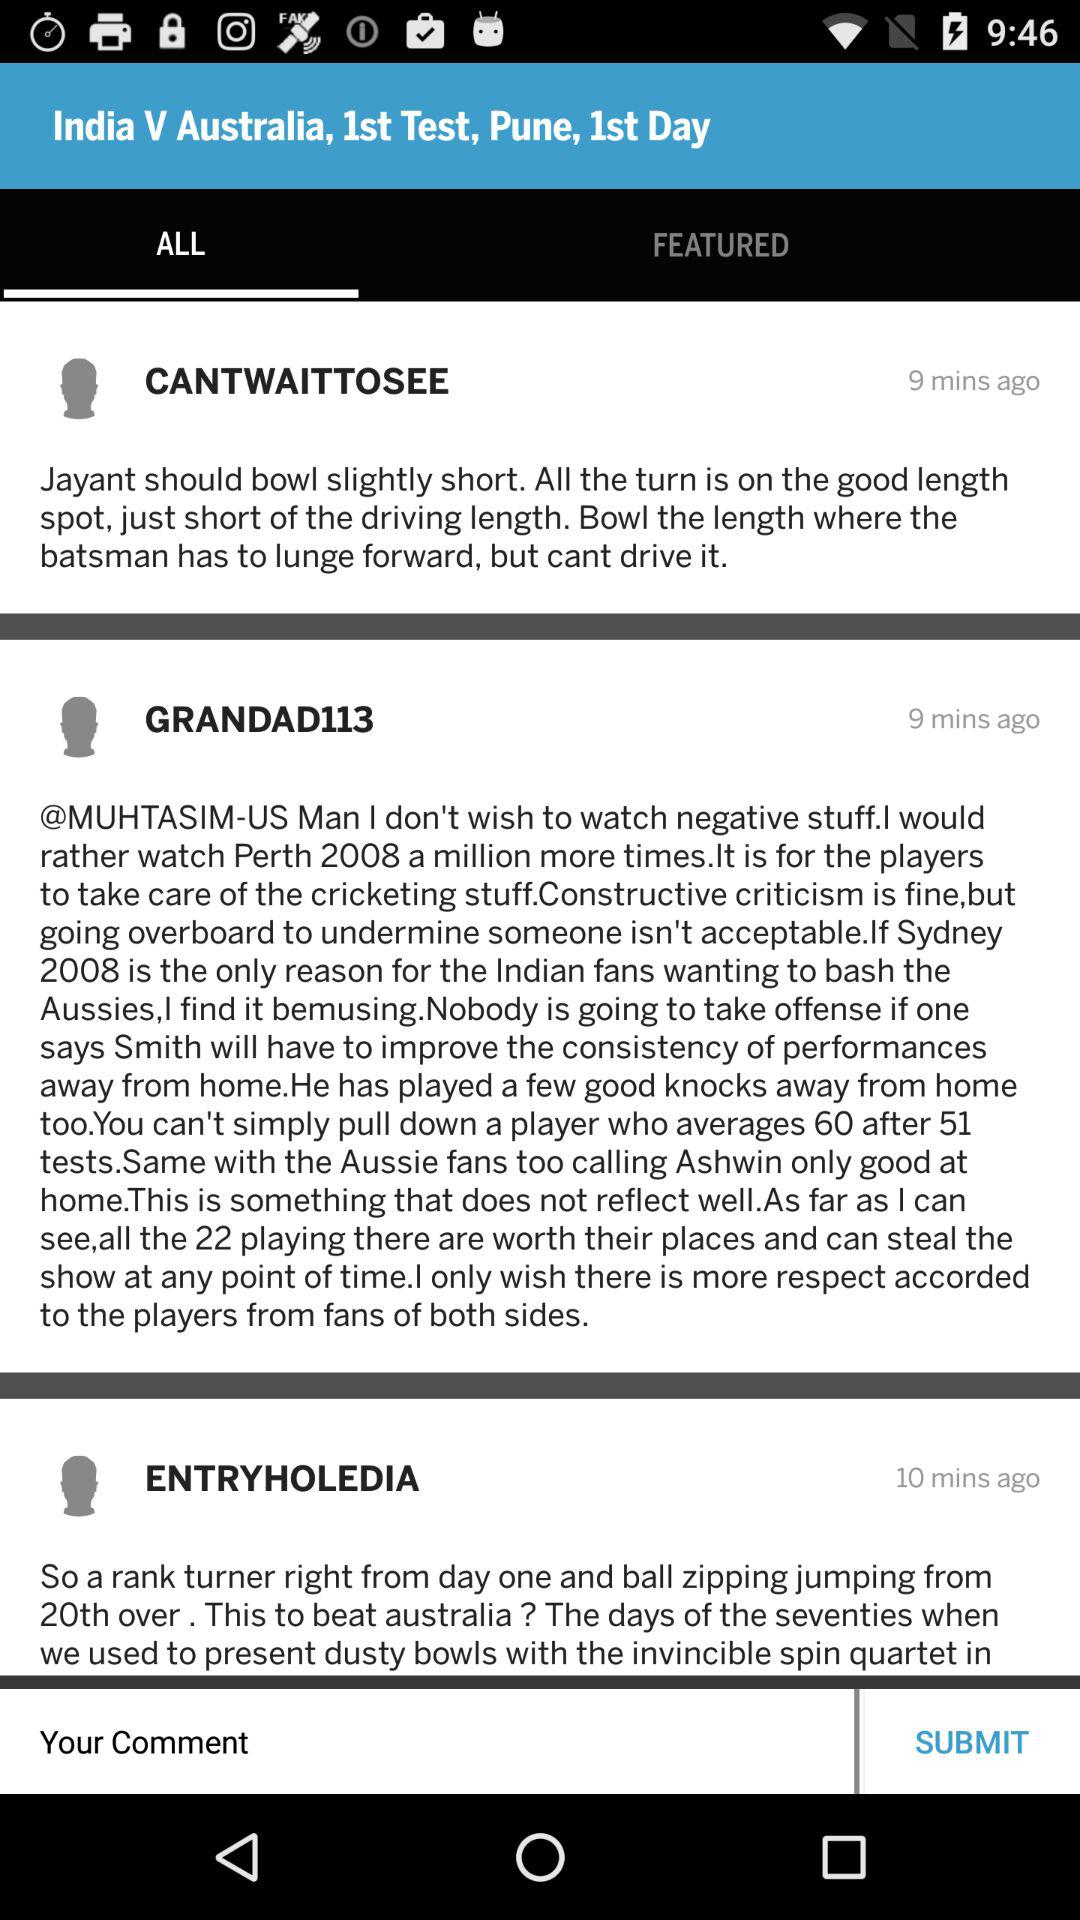How many minutes ago did "CANTWAITTOSEE" post a comment? "CANTWAITTOSEE" posted a comment 9 minutes ago. 